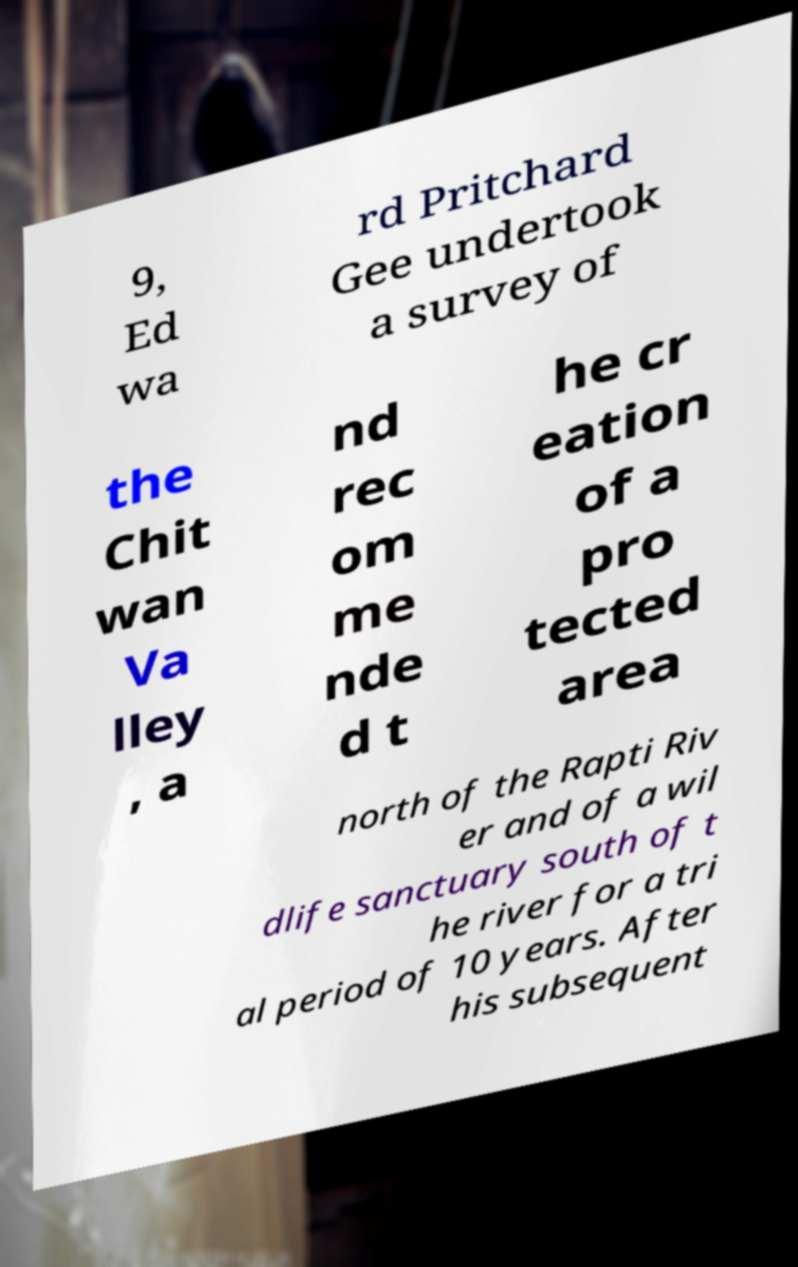Could you extract and type out the text from this image? 9, Ed wa rd Pritchard Gee undertook a survey of the Chit wan Va lley , a nd rec om me nde d t he cr eation of a pro tected area north of the Rapti Riv er and of a wil dlife sanctuary south of t he river for a tri al period of 10 years. After his subsequent 